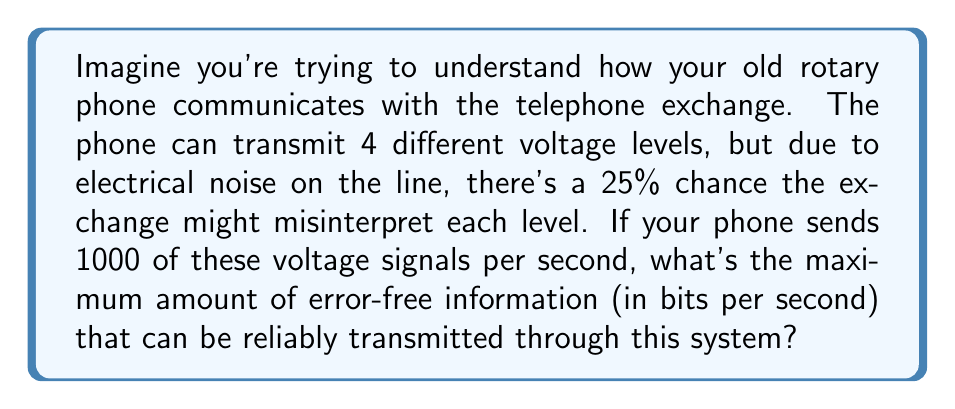Help me with this question. Let's break this down step-by-step:

1) First, we need to understand the components of Shannon's channel capacity formula:

   $$C = B \log_2(1 + \frac{S}{N})$$

   Where:
   $C$ is the channel capacity in bits per second
   $B$ is the bandwidth in Hz
   $S$ is the signal power
   $N$ is the noise power

2) In this case, we don't have explicit S and N values. Instead, we have a discrete channel with 4 possible inputs and some probability of error. We need to use a different form of the capacity formula:

   $$C = B \cdot (H(X) - H(X|Y))$$

   Where:
   $H(X)$ is the entropy of the input
   $H(X|Y)$ is the conditional entropy of the input given the output

3) We know $B = 1000$ Hz (1000 signals per second)

4) For $H(X)$, we have 4 equally likely inputs, so:
   
   $$H(X) = -\sum_{i=1}^4 p(x_i) \log_2 p(x_i) = -4 \cdot \frac{1}{4} \log_2 \frac{1}{4} = 2 \text{ bits}$$

5) For $H(X|Y)$, we need to consider the error probability. There's a 75% chance of correct transmission and 25% chance of error:

   $$H(X|Y) = -[0.75 \log_2 0.75 + 0.25 \log_2 (\frac{0.25}{3})] \approx 0.8113 \text{ bits}$$

6) Now we can calculate the capacity:

   $$C = 1000 \cdot (2 - 0.8113) = 1000 \cdot 1.1887 = 1188.7 \text{ bits per second}$$
Answer: $$1188.7 \text{ bits per second}$$ 